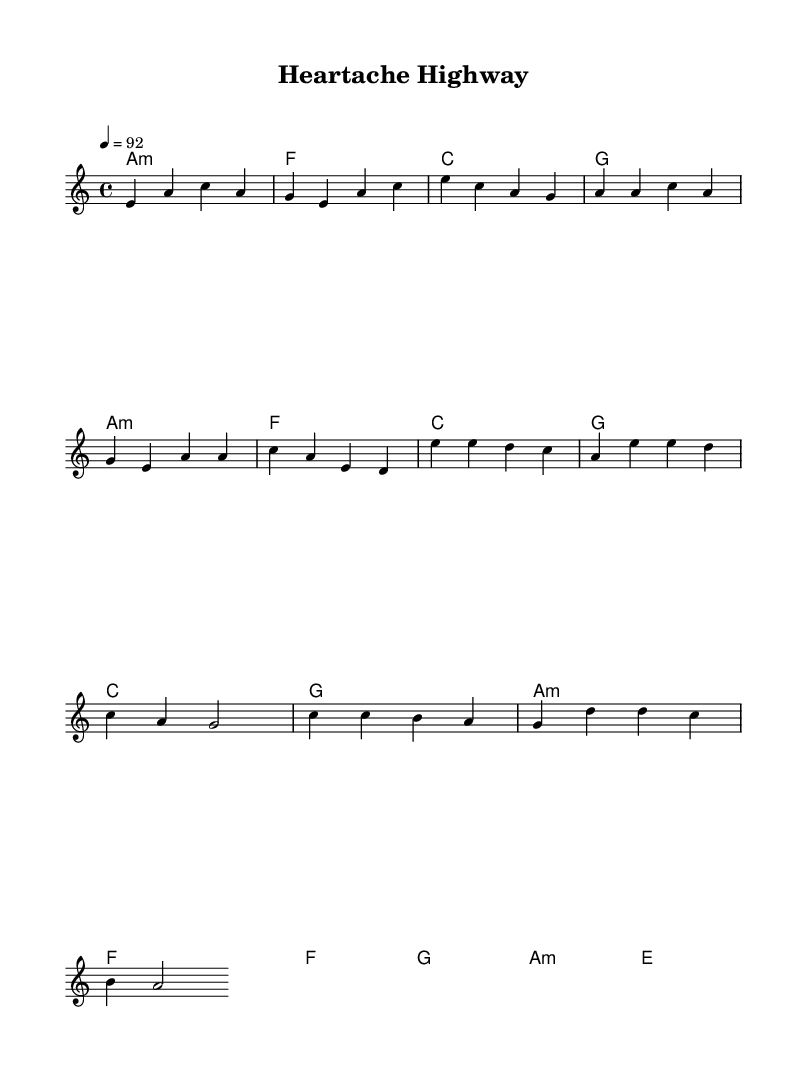What is the key signature of this music? The key signature is A minor, which has no sharps or flats. This is determined from the 'a' indicated in the global context settings of the sheet music.
Answer: A minor What is the time signature of this music? The time signature is 4/4, indicated in the global settings. This tells us that there are four beats in each measure and that a quarter note receives one beat.
Answer: 4/4 What is the tempo marking of this piece? The tempo marking is quarter note = 92, shown in the global section of the score. This indicates how fast the music should be played.
Answer: 92 What chord is played in the chorus section? The primary chord in the chorus is C major, which is indicated in the harmonies section above the melody in the chorus part.
Answer: C How many measures are in the verse? There are six measures in the verse, as counted from the melody section, where the verse is defined with specific notes.
Answer: 6 Which two genres does "Heartache Highway" blend? The title and lyrics suggest that it blends blues and pop, as indicated in the chorus lyric "where the blues and pop collide," showing the crossover appeal.
Answer: Blues and pop What is the last chord in the bridge section? The last chord in the bridge is E major, which is indicated explicitly in the harmonies of that section.
Answer: E 